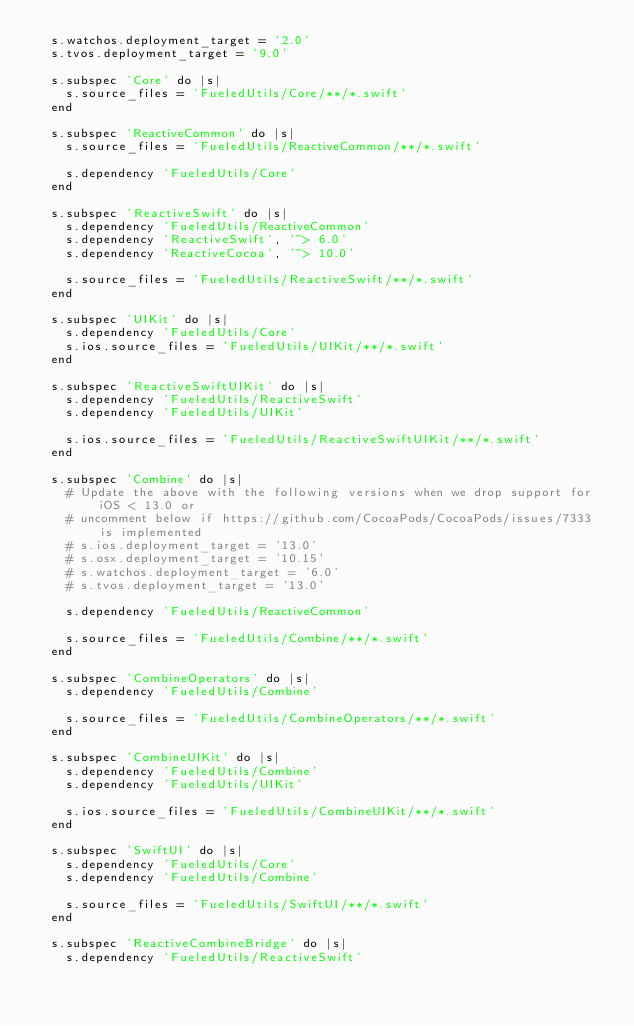<code> <loc_0><loc_0><loc_500><loc_500><_Ruby_>  s.watchos.deployment_target = '2.0'
  s.tvos.deployment_target = '9.0'

  s.subspec 'Core' do |s|
    s.source_files = 'FueledUtils/Core/**/*.swift'
  end

  s.subspec 'ReactiveCommon' do |s|
    s.source_files = 'FueledUtils/ReactiveCommon/**/*.swift'

    s.dependency 'FueledUtils/Core'
  end

  s.subspec 'ReactiveSwift' do |s|
    s.dependency 'FueledUtils/ReactiveCommon'
    s.dependency 'ReactiveSwift', '~> 6.0'
    s.dependency 'ReactiveCocoa', '~> 10.0'

    s.source_files = 'FueledUtils/ReactiveSwift/**/*.swift'
  end

  s.subspec 'UIKit' do |s|
    s.dependency 'FueledUtils/Core'
    s.ios.source_files = 'FueledUtils/UIKit/**/*.swift'
  end

  s.subspec 'ReactiveSwiftUIKit' do |s|
    s.dependency 'FueledUtils/ReactiveSwift'
    s.dependency 'FueledUtils/UIKit'

    s.ios.source_files = 'FueledUtils/ReactiveSwiftUIKit/**/*.swift'
  end

  s.subspec 'Combine' do |s|
    # Update the above with the following versions when we drop support for iOS < 13.0 or
    # uncomment below if https://github.com/CocoaPods/CocoaPods/issues/7333 is implemented
    # s.ios.deployment_target = '13.0'
    # s.osx.deployment_target = '10.15'
    # s.watchos.deployment_target = '6.0'
    # s.tvos.deployment_target = '13.0'

    s.dependency 'FueledUtils/ReactiveCommon'

    s.source_files = 'FueledUtils/Combine/**/*.swift'
  end

  s.subspec 'CombineOperators' do |s|
    s.dependency 'FueledUtils/Combine'

    s.source_files = 'FueledUtils/CombineOperators/**/*.swift'
  end

  s.subspec 'CombineUIKit' do |s|
    s.dependency 'FueledUtils/Combine'
    s.dependency 'FueledUtils/UIKit'

    s.ios.source_files = 'FueledUtils/CombineUIKit/**/*.swift'
  end

  s.subspec 'SwiftUI' do |s|
    s.dependency 'FueledUtils/Core'
    s.dependency 'FueledUtils/Combine'

    s.source_files = 'FueledUtils/SwiftUI/**/*.swift'
  end

  s.subspec 'ReactiveCombineBridge' do |s|
    s.dependency 'FueledUtils/ReactiveSwift'</code> 